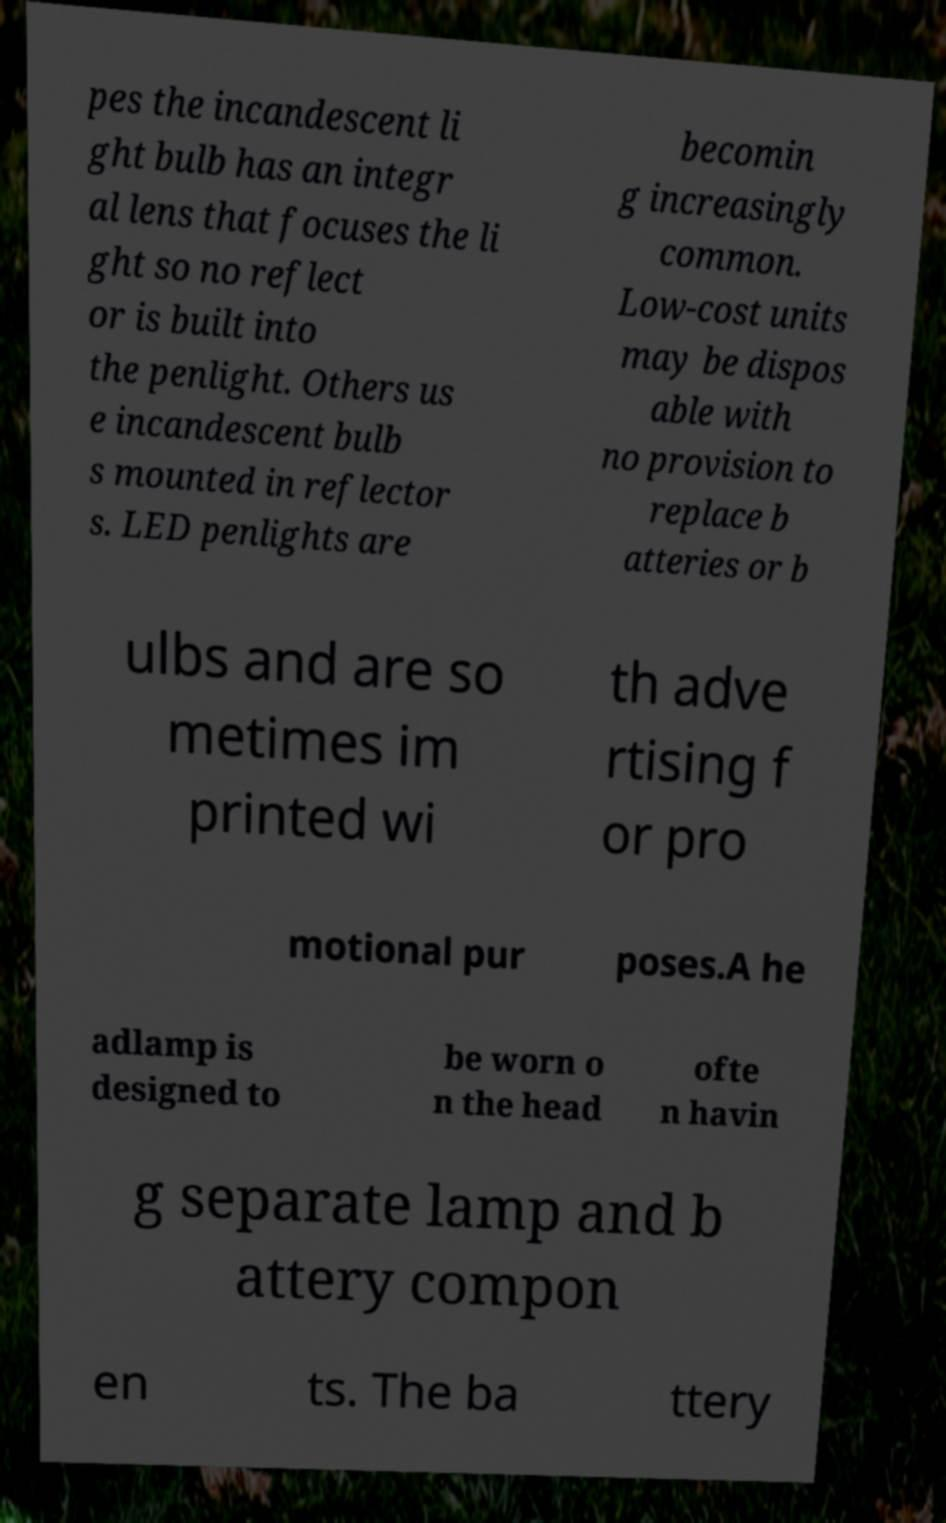Please identify and transcribe the text found in this image. pes the incandescent li ght bulb has an integr al lens that focuses the li ght so no reflect or is built into the penlight. Others us e incandescent bulb s mounted in reflector s. LED penlights are becomin g increasingly common. Low-cost units may be dispos able with no provision to replace b atteries or b ulbs and are so metimes im printed wi th adve rtising f or pro motional pur poses.A he adlamp is designed to be worn o n the head ofte n havin g separate lamp and b attery compon en ts. The ba ttery 